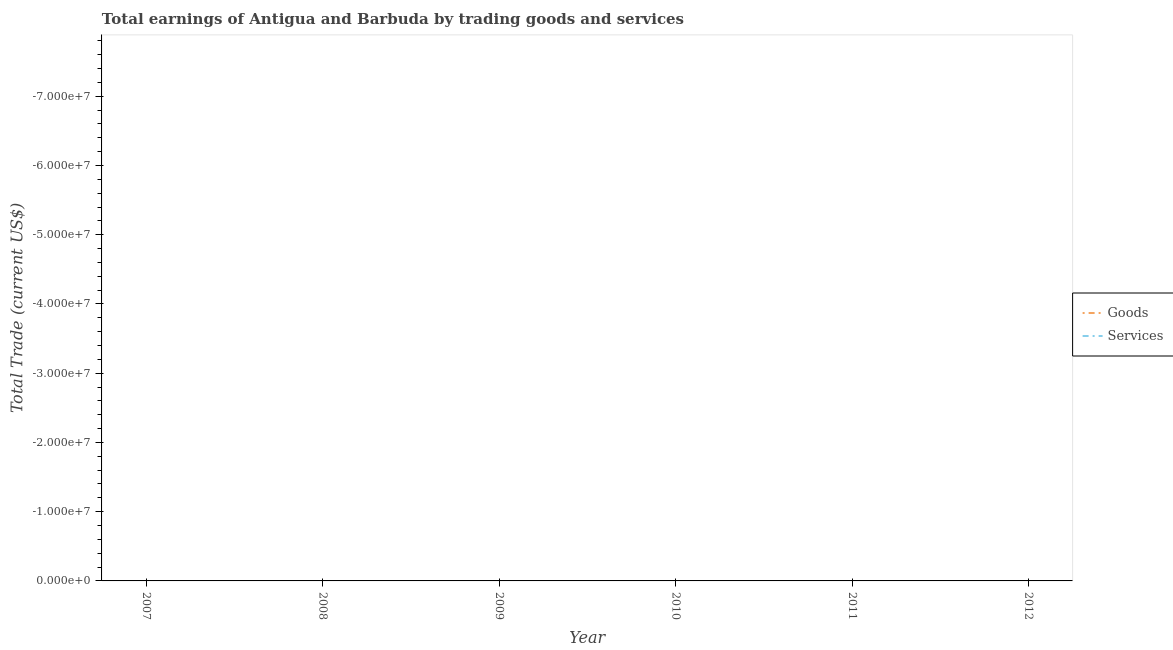How many different coloured lines are there?
Provide a short and direct response. 0. Does the line corresponding to amount earned by trading goods intersect with the line corresponding to amount earned by trading services?
Offer a terse response. No. What is the total amount earned by trading goods in the graph?
Offer a terse response. 0. What is the difference between the amount earned by trading goods in 2007 and the amount earned by trading services in 2011?
Your answer should be very brief. 0. What is the average amount earned by trading goods per year?
Ensure brevity in your answer.  0. In how many years, is the amount earned by trading services greater than -28000000 US$?
Your response must be concise. 0. How many years are there in the graph?
Your answer should be very brief. 6. Does the graph contain grids?
Keep it short and to the point. No. How are the legend labels stacked?
Give a very brief answer. Vertical. What is the title of the graph?
Provide a succinct answer. Total earnings of Antigua and Barbuda by trading goods and services. Does "Time to export" appear as one of the legend labels in the graph?
Your answer should be compact. No. What is the label or title of the X-axis?
Ensure brevity in your answer.  Year. What is the label or title of the Y-axis?
Offer a terse response. Total Trade (current US$). What is the Total Trade (current US$) in Goods in 2008?
Provide a short and direct response. 0. What is the Total Trade (current US$) in Services in 2008?
Your answer should be very brief. 0. What is the Total Trade (current US$) of Goods in 2009?
Your response must be concise. 0. What is the Total Trade (current US$) in Services in 2010?
Your response must be concise. 0. What is the Total Trade (current US$) in Goods in 2011?
Provide a succinct answer. 0. What is the Total Trade (current US$) of Goods in 2012?
Keep it short and to the point. 0. What is the Total Trade (current US$) of Services in 2012?
Your answer should be very brief. 0. What is the total Total Trade (current US$) in Goods in the graph?
Provide a succinct answer. 0. What is the average Total Trade (current US$) of Goods per year?
Give a very brief answer. 0. What is the average Total Trade (current US$) in Services per year?
Ensure brevity in your answer.  0. 